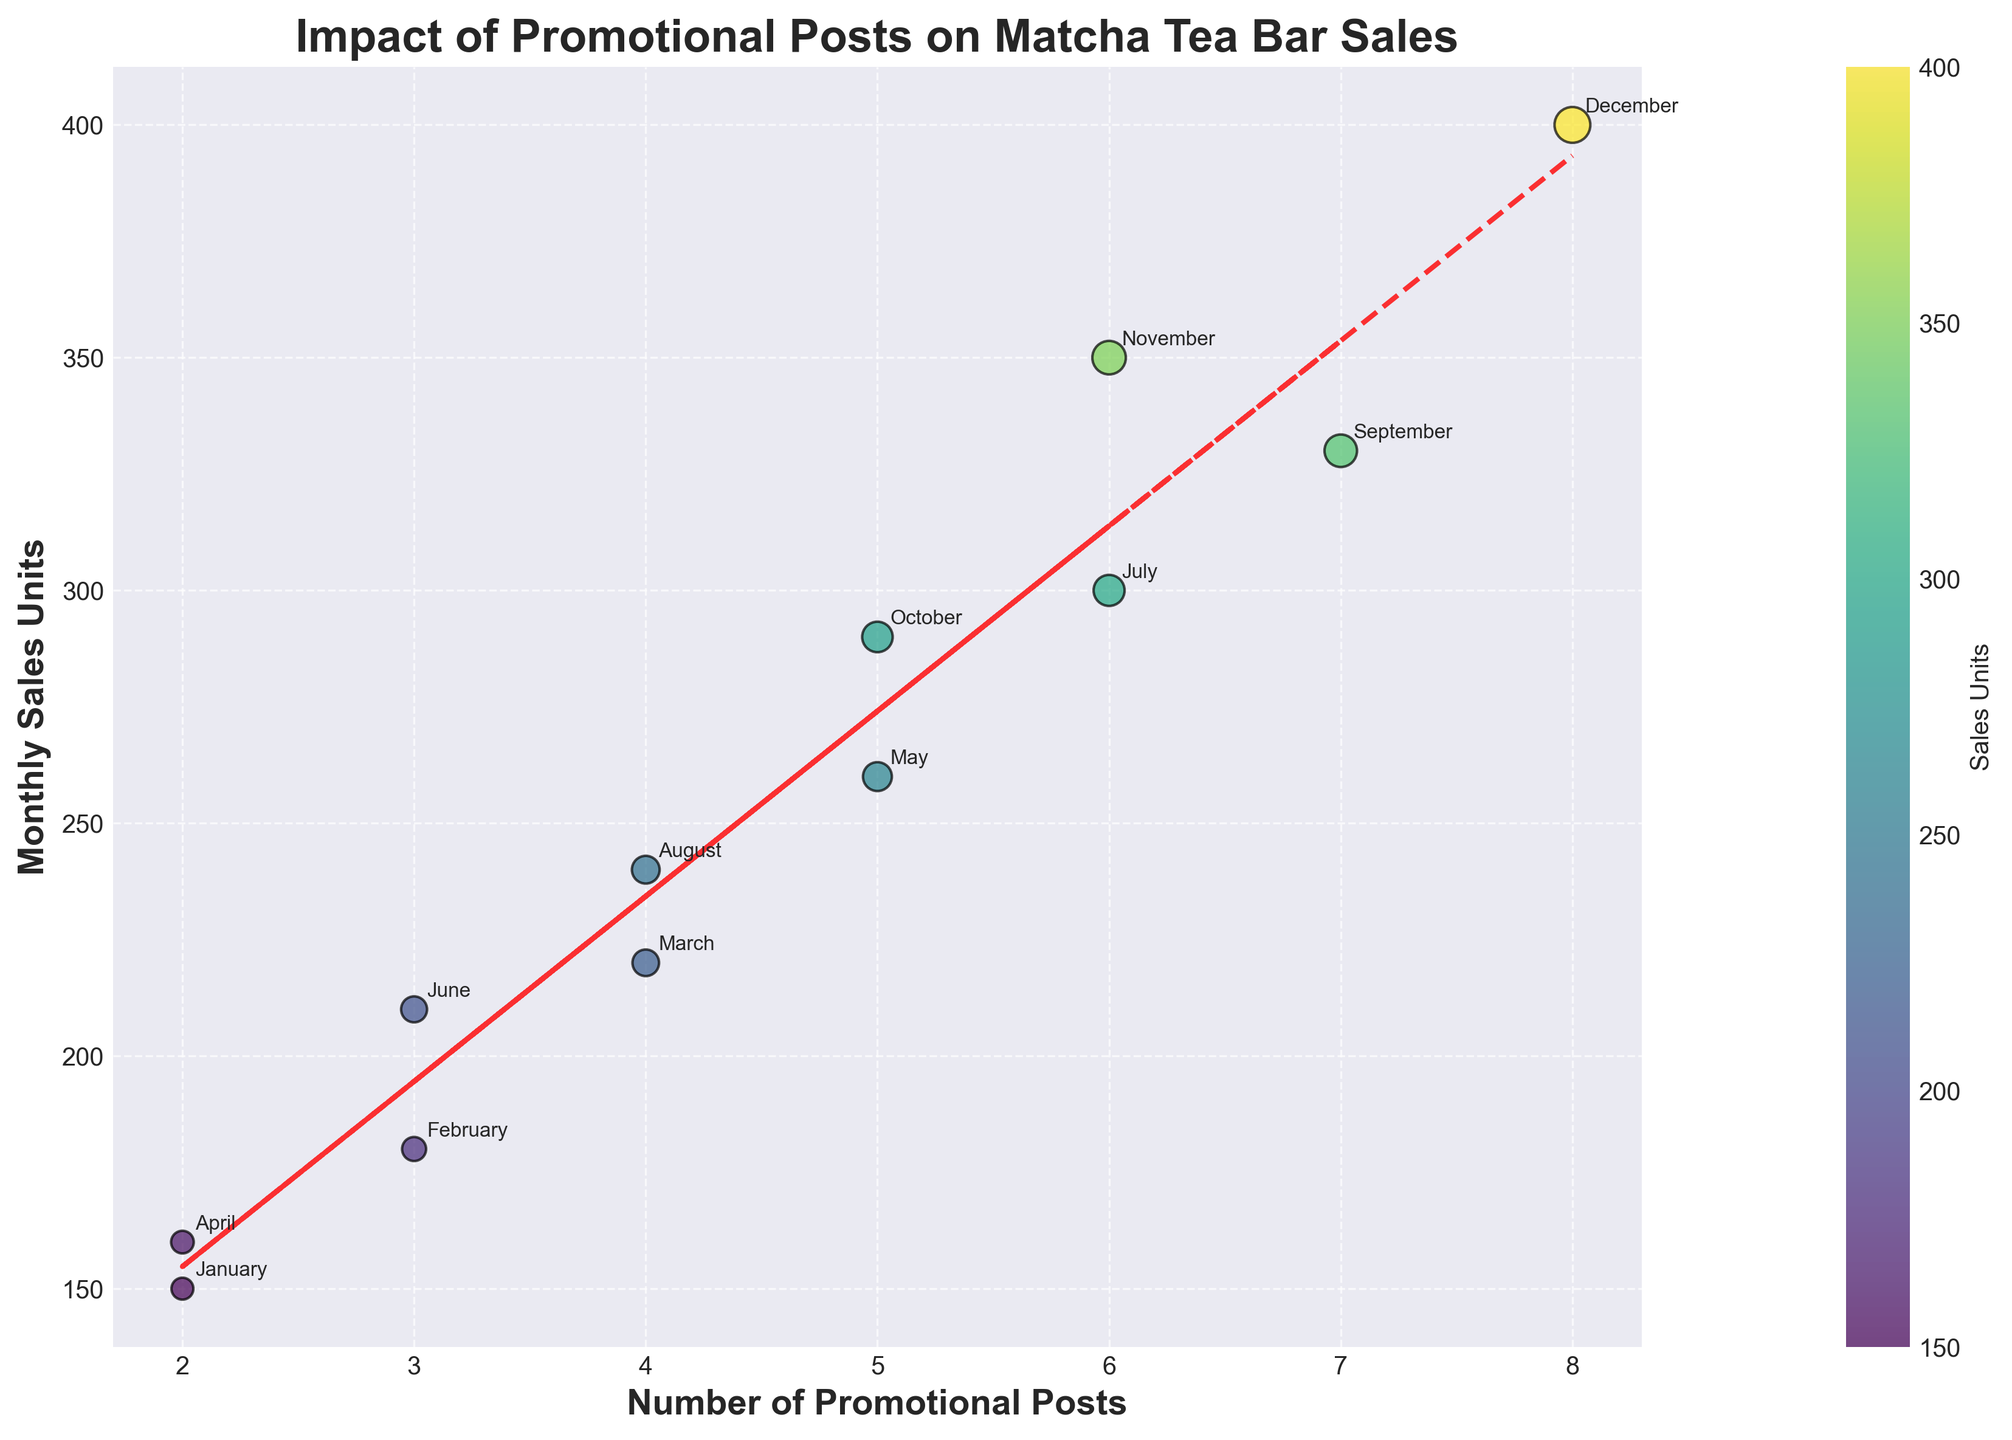What is the title of the scatter plot? Look at the top of the plot where the title is displayed. The title is written in bold letters.
Answer: Impact of Promotional Posts on Matcha Tea Bar Sales How many months had exactly 5 promotional posts? Count the number of data points that lie on the x-axis value of 5.
Answer: 2 What is the monthly sales figure for October? Locate October's data point on the plot and look at its corresponding y-axis value.
Answer: 290 Which month had the highest number of promotional posts? Look for the data point that is farthest on the right on the x-axis.
Answer: December What is the range of monthly sales units shown in this plot? Identify the minimum and maximum y-axis values among the data points. Subtract the minimum from the maximum value.
Answer: 250 Does increasing the number of promotional posts generally lead to higher monthly sales? Observe the overall trend of the data points and the direction of the fitted line.
Answer: Yes Which month had a sales unit of 330? Locate the data point on the y-axis at 330 and see which month is annotated next to it.
Answer: September What is the fitted line's equation? Examine the red dashed line representing the linear trend. The equation is displayed near this line.
Answer: y = 32.7x + 109.1 How many months are displayed on the plot? Count the annotated data points, as each represents one month.
Answer: 12 What were the monthly sales units for February and how did it compare with June? Find the y-axis values for February and June, then compare the two. February is 180 and June is 210, so June had higher sales.
Answer: February: 180, June: 210 